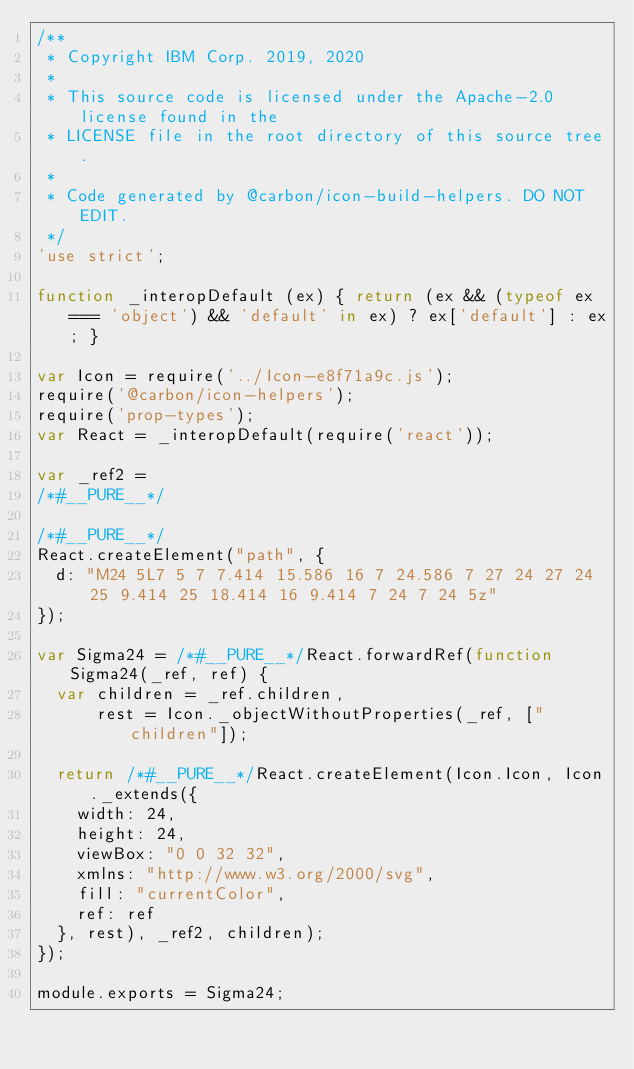Convert code to text. <code><loc_0><loc_0><loc_500><loc_500><_JavaScript_>/**
 * Copyright IBM Corp. 2019, 2020
 *
 * This source code is licensed under the Apache-2.0 license found in the
 * LICENSE file in the root directory of this source tree.
 *
 * Code generated by @carbon/icon-build-helpers. DO NOT EDIT.
 */
'use strict';

function _interopDefault (ex) { return (ex && (typeof ex === 'object') && 'default' in ex) ? ex['default'] : ex; }

var Icon = require('../Icon-e8f71a9c.js');
require('@carbon/icon-helpers');
require('prop-types');
var React = _interopDefault(require('react'));

var _ref2 =
/*#__PURE__*/

/*#__PURE__*/
React.createElement("path", {
  d: "M24 5L7 5 7 7.414 15.586 16 7 24.586 7 27 24 27 24 25 9.414 25 18.414 16 9.414 7 24 7 24 5z"
});

var Sigma24 = /*#__PURE__*/React.forwardRef(function Sigma24(_ref, ref) {
  var children = _ref.children,
      rest = Icon._objectWithoutProperties(_ref, ["children"]);

  return /*#__PURE__*/React.createElement(Icon.Icon, Icon._extends({
    width: 24,
    height: 24,
    viewBox: "0 0 32 32",
    xmlns: "http://www.w3.org/2000/svg",
    fill: "currentColor",
    ref: ref
  }, rest), _ref2, children);
});

module.exports = Sigma24;
</code> 